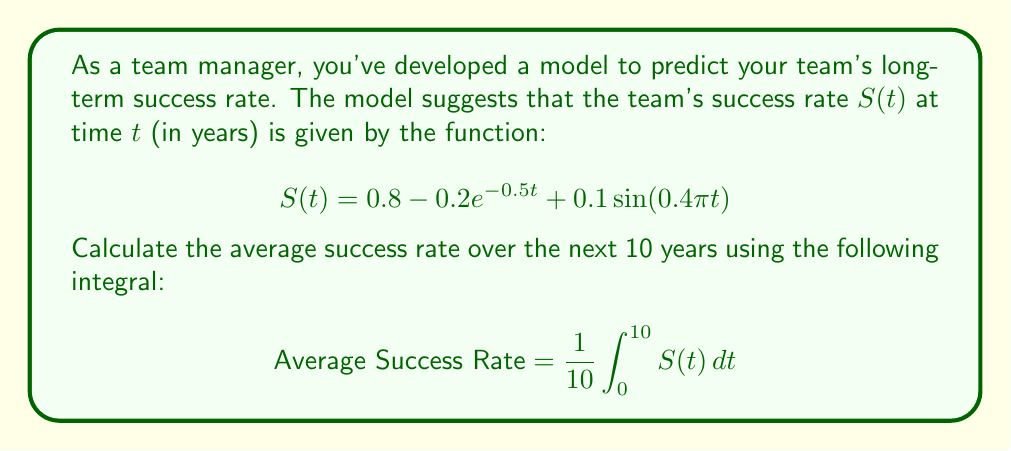Help me with this question. To solve this problem, we need to integrate the given function $S(t)$ over the interval $[0, 10]$ and then divide by 10 to find the average. Let's break it down step-by-step:

1) First, let's separate the integral into three parts:

   $$\frac{1}{10}\int_0^{10} (0.8 - 0.2e^{-0.5t} + 0.1\sin(0.4\pi t)) \, dt$$

2) Now, let's integrate each part separately:

   a) $\frac{1}{10}\int_0^{10} 0.8 \, dt = 0.8t \big|_0^{10} = 0.8$

   b) $-\frac{1}{10}\int_0^{10} 0.2e^{-0.5t} \, dt = -\frac{0.4}{10}\int_0^{10} e^{-0.5t} \, dt$
      $= -\frac{0.4}{10}[-2e^{-0.5t}] \big|_0^{10} = -\frac{0.4}{10}[-2e^{-5} + 2] = 0.08 - 0.08e^{-5}$

   c) $\frac{1}{10}\int_0^{10} 0.1\sin(0.4\pi t) \, dt = \frac{0.1}{10}\int_0^{10} \sin(0.4\pi t) \, dt$
      $= \frac{0.1}{10}[-\frac{1}{0.4\pi}\cos(0.4\pi t)] \big|_0^{10} = \frac{0.1}{4\pi}[-\cos(4\pi) + 1] = \frac{0.05}{\pi}$

3) Adding these results together:

   Average Success Rate $= 0.8 + (0.08 - 0.08e^{-5}) + \frac{0.05}{\pi}$

4) Simplifying:

   Average Success Rate $\approx 0.8961$
Answer: The average success rate over the next 10 years is approximately 0.8961 or 89.61%. 